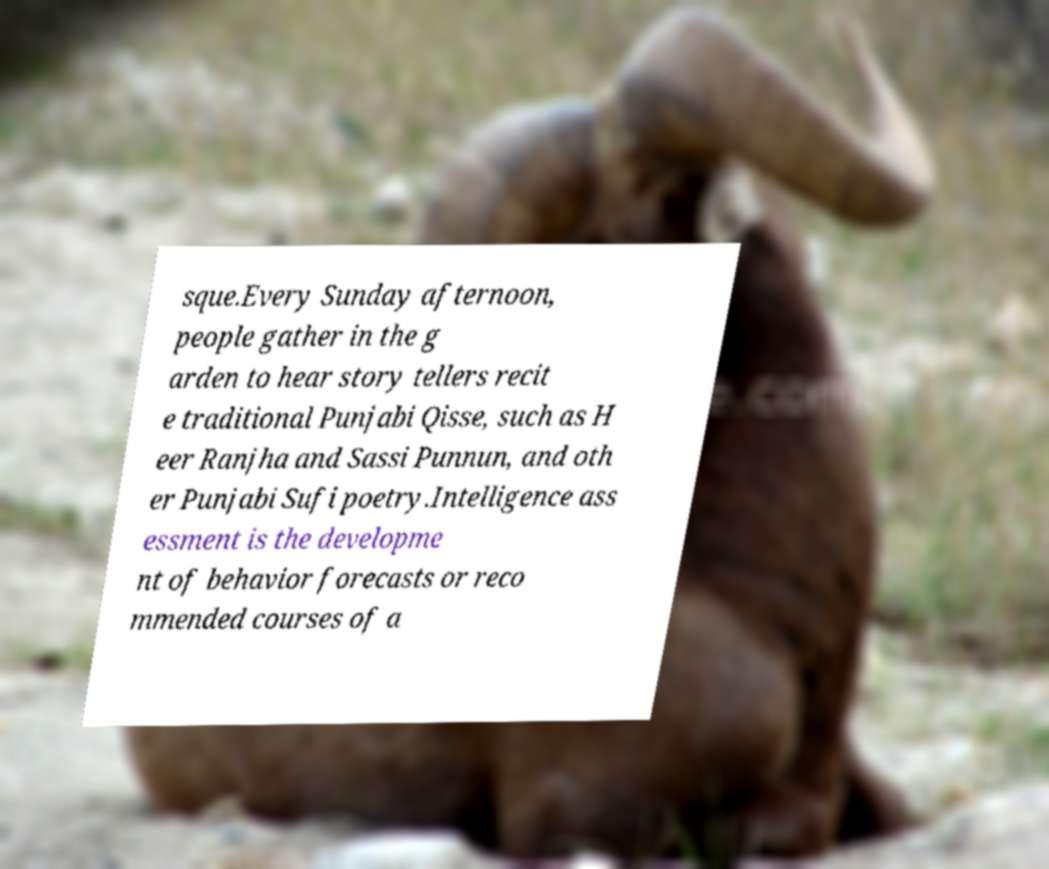Could you extract and type out the text from this image? sque.Every Sunday afternoon, people gather in the g arden to hear story tellers recit e traditional Punjabi Qisse, such as H eer Ranjha and Sassi Punnun, and oth er Punjabi Sufi poetry.Intelligence ass essment is the developme nt of behavior forecasts or reco mmended courses of a 